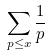Convert formula to latex. <formula><loc_0><loc_0><loc_500><loc_500>\sum _ { p \leq x } \frac { 1 } { p }</formula> 